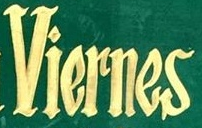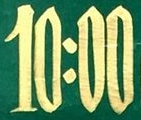What text is displayed in these images sequentially, separated by a semicolon? Viernes; 10:00 